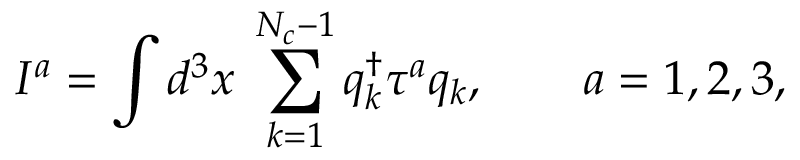<formula> <loc_0><loc_0><loc_500><loc_500>I ^ { a } = \int d ^ { 3 } x \, \sum _ { k = 1 } ^ { N _ { c } - 1 } q _ { k } ^ { \dag } \tau ^ { a } q _ { k } , \quad a = 1 , 2 , 3 ,</formula> 